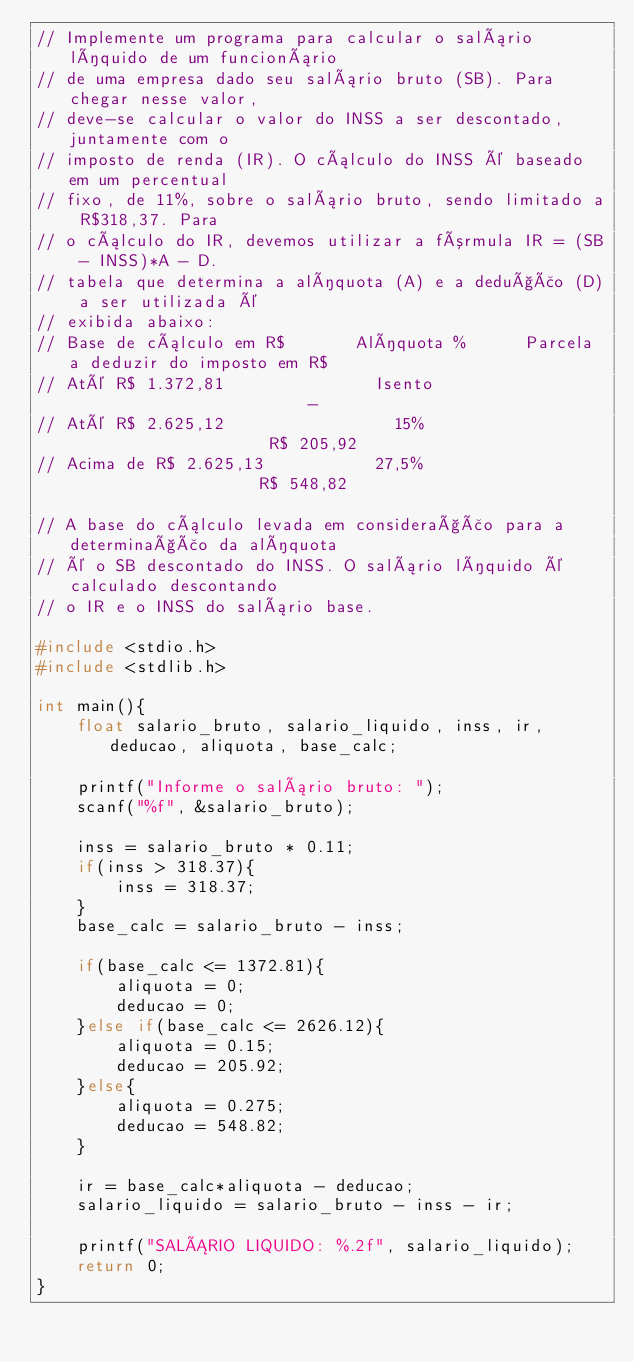Convert code to text. <code><loc_0><loc_0><loc_500><loc_500><_C_>// Implemente um programa para calcular o salário líquido de um funcionário
// de uma empresa dado seu salário bruto (SB). Para chegar nesse valor,
// deve-se calcular o valor do INSS a ser descontado, juntamente com o
// imposto de renda (IR). O cálculo do INSS é baseado em um percentual
// fixo, de 11%, sobre o salário bruto, sendo limitado a R$318,37. Para
// o cálculo do IR, devemos utilizar a fórmula IR = (SB - INSS)*A - D.
// tabela que determina a alíquota (A) e a dedução (D) a ser utilizada é
// exibida abaixo:
// Base de cálculo em R$       Alíquota %      Parcela a deduzir do imposto em R$
// Até R$ 1.372,81               Isento                         -
// Até R$ 2.625,12                 15%                     R$ 205,92
// Acima de R$ 2.625,13           27,5%                    R$ 548,82

// A base do cálculo levada em consideração para a determinação da alíquota
// é o SB descontado do INSS. O salário líquido é calculado descontando
// o IR e o INSS do salário base.

#include <stdio.h>
#include <stdlib.h>

int main(){
    float salario_bruto, salario_liquido, inss, ir, deducao, aliquota, base_calc;

    printf("Informe o salário bruto: ");
    scanf("%f", &salario_bruto);

    inss = salario_bruto * 0.11;
    if(inss > 318.37){
        inss = 318.37;
    }
    base_calc = salario_bruto - inss;

    if(base_calc <= 1372.81){
        aliquota = 0;
        deducao = 0;
    }else if(base_calc <= 2626.12){
        aliquota = 0.15;
        deducao = 205.92;
    }else{
        aliquota = 0.275;
        deducao = 548.82;
    }

    ir = base_calc*aliquota - deducao;
    salario_liquido = salario_bruto - inss - ir;

    printf("SALÁRIO LIQUIDO: %.2f", salario_liquido);
    return 0;
}</code> 